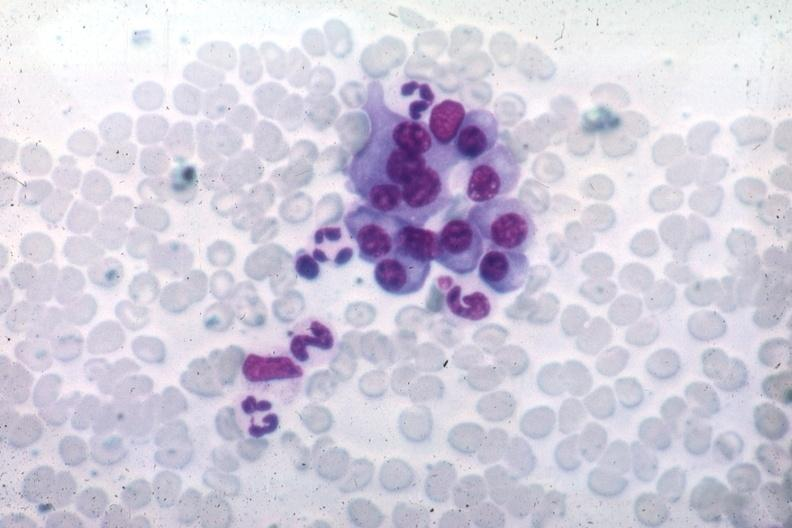s plasma cell present?
Answer the question using a single word or phrase. Yes 